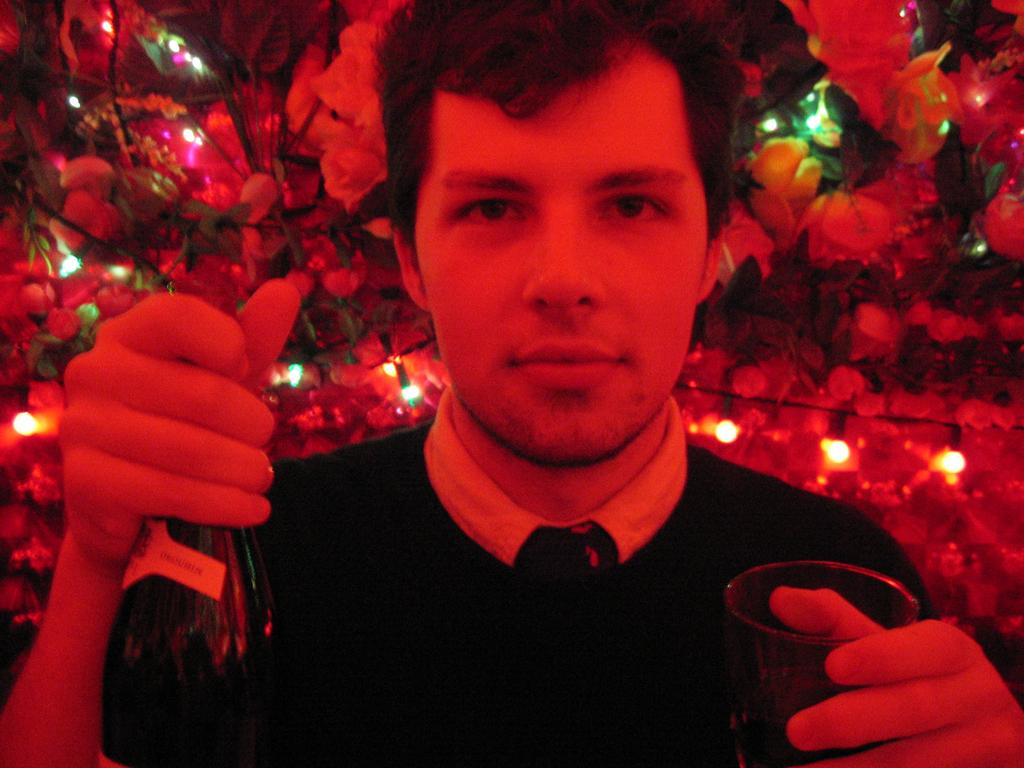Who is present in the image? There is a man in the image. What is the man holding in his hands? The man is holding a bottle and a glass. What can be seen in the background of the image? There are artificial trees and decorative lights in the background of the image. What type of brush is the man using to mix the eggnog in the image? There is no brush or eggnog present in the image. 